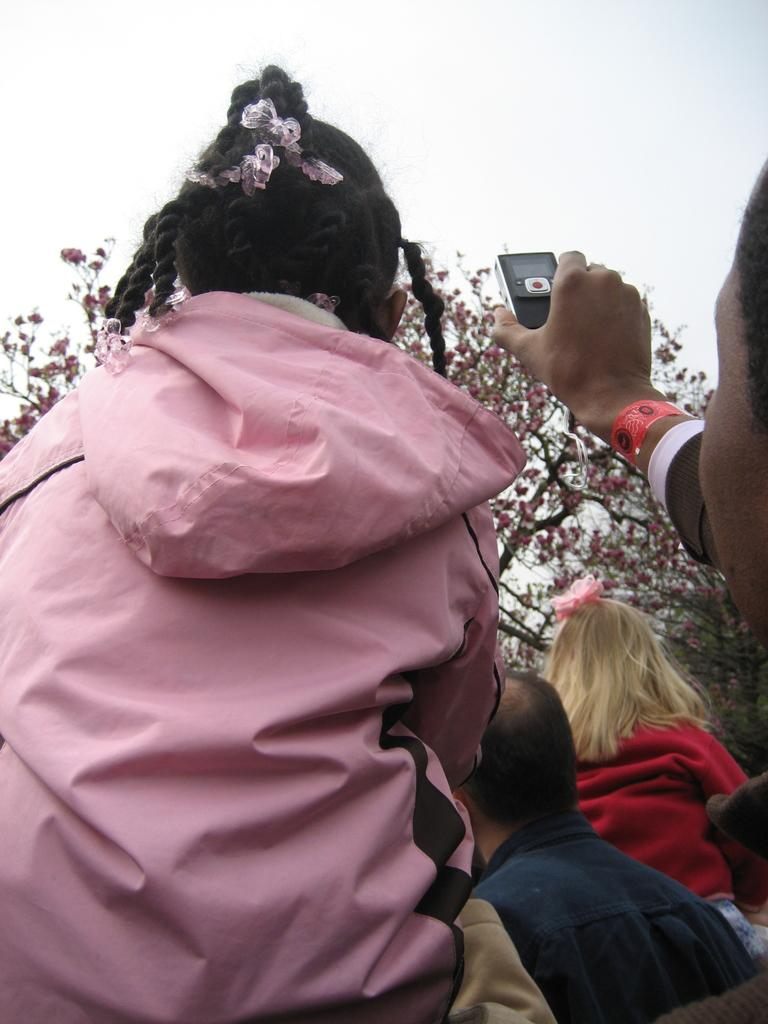How many people are in the image? There are people in the image, but the exact number is not specified. What is the person holding in their hand? There is a gadget being held in someone's hand in the image. What can be seen in the background of the image? There are trees and the sky visible in the background of the image. What type of bone can be seen sticking out of the person's arm in the image? There is no bone visible in the image, nor is there any indication of an injury or medical situation. 